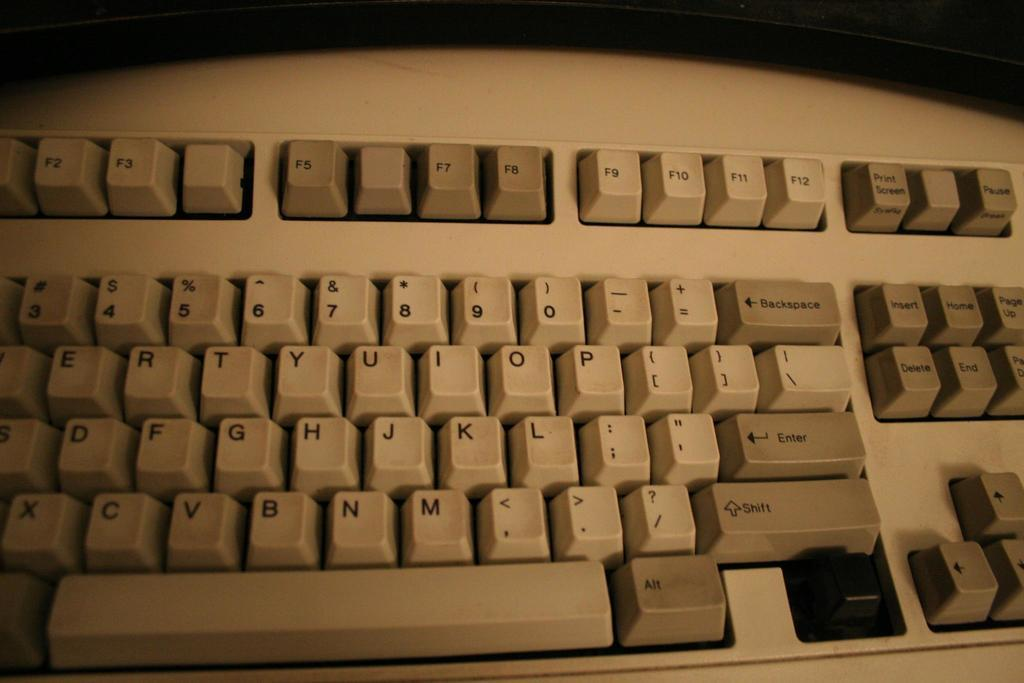Provide a one-sentence caption for the provided image. A keyboard has all of its keys including the shift and enter keys. 